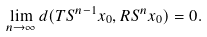Convert formula to latex. <formula><loc_0><loc_0><loc_500><loc_500>\lim _ { n \to \infty } d ( T S ^ { n - 1 } x _ { 0 } , R S ^ { n } x _ { 0 } ) = 0 .</formula> 